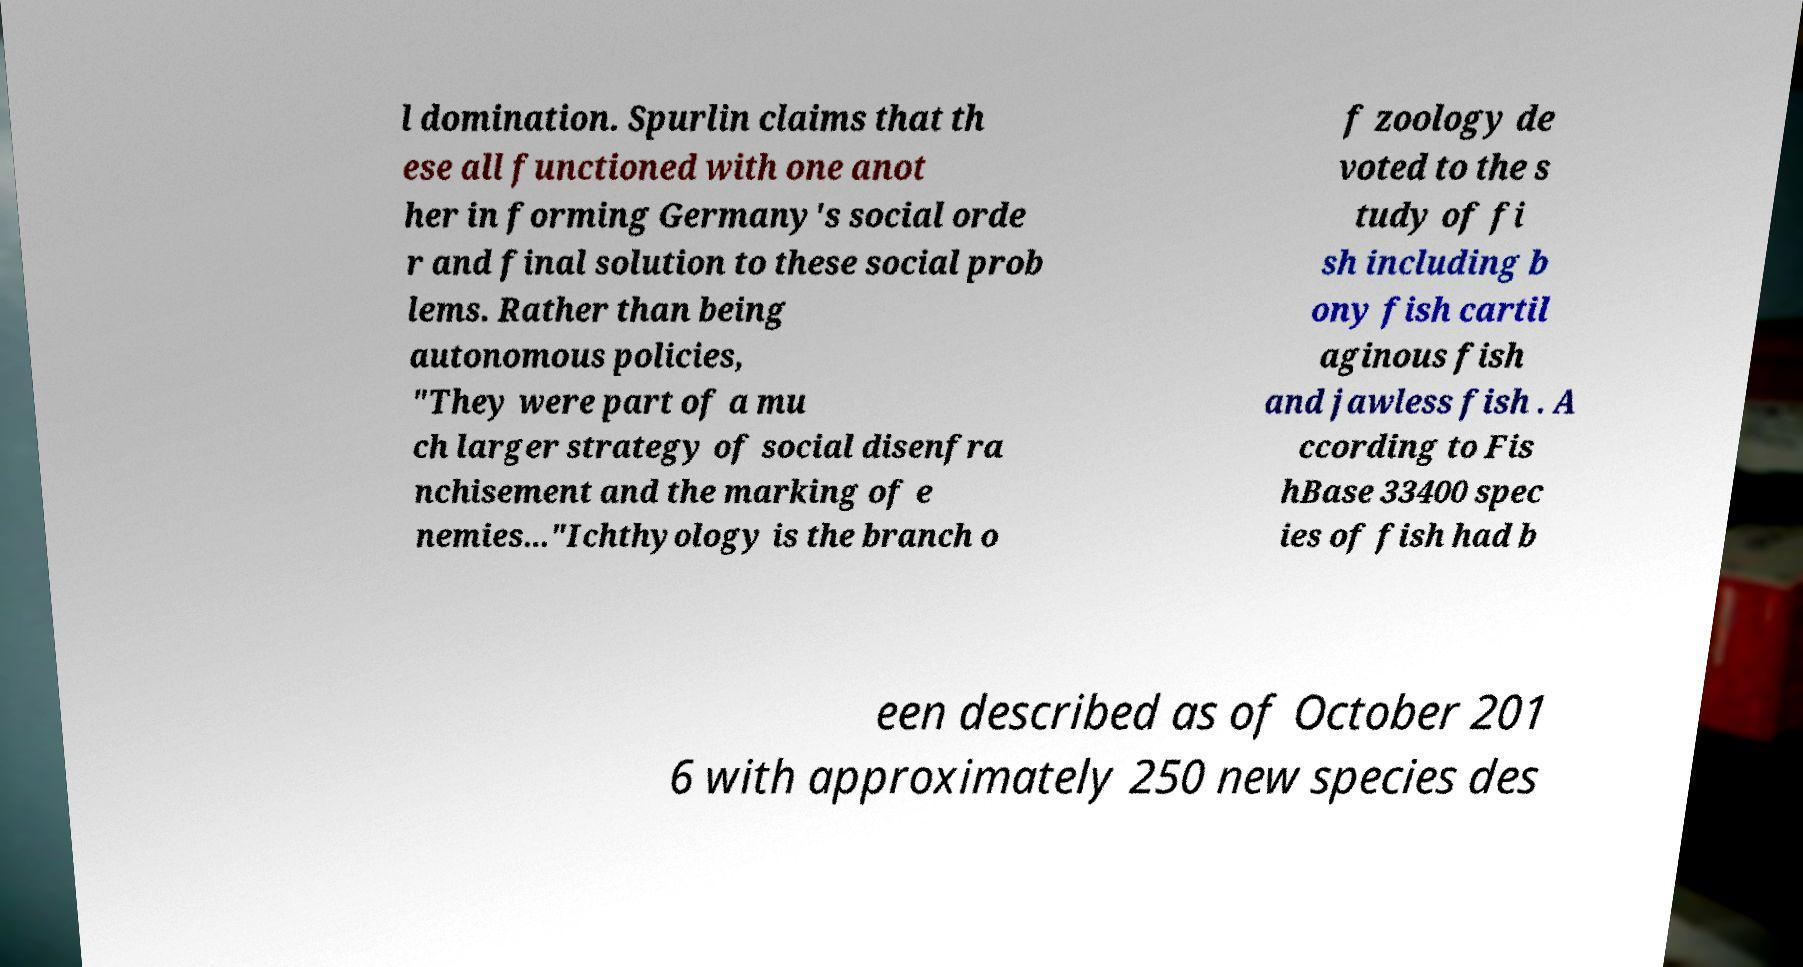Please read and relay the text visible in this image. What does it say? l domination. Spurlin claims that th ese all functioned with one anot her in forming Germany's social orde r and final solution to these social prob lems. Rather than being autonomous policies, "They were part of a mu ch larger strategy of social disenfra nchisement and the marking of e nemies..."Ichthyology is the branch o f zoology de voted to the s tudy of fi sh including b ony fish cartil aginous fish and jawless fish . A ccording to Fis hBase 33400 spec ies of fish had b een described as of October 201 6 with approximately 250 new species des 